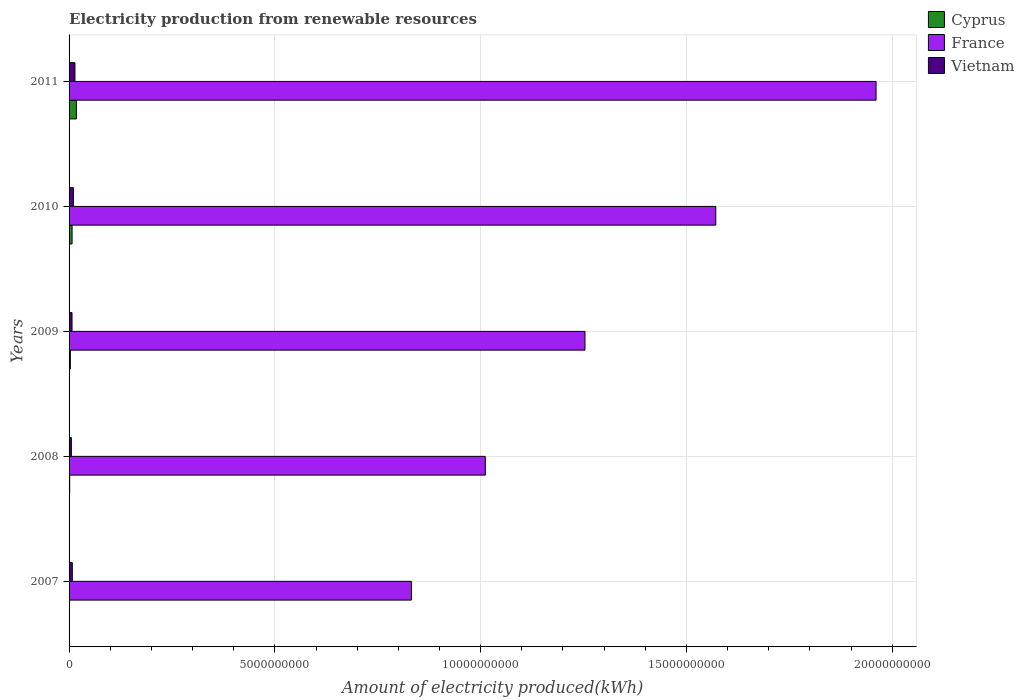How many different coloured bars are there?
Ensure brevity in your answer.  3. How many groups of bars are there?
Provide a succinct answer. 5. Are the number of bars per tick equal to the number of legend labels?
Your answer should be compact. Yes. Are the number of bars on each tick of the Y-axis equal?
Your answer should be very brief. Yes. How many bars are there on the 4th tick from the bottom?
Make the answer very short. 3. What is the label of the 5th group of bars from the top?
Give a very brief answer. 2007. What is the amount of electricity produced in Vietnam in 2010?
Your answer should be very brief. 1.05e+08. Across all years, what is the maximum amount of electricity produced in France?
Provide a short and direct response. 1.96e+1. Across all years, what is the minimum amount of electricity produced in Cyprus?
Give a very brief answer. 3.00e+06. What is the total amount of electricity produced in Vietnam in the graph?
Give a very brief answer. 4.55e+08. What is the difference between the amount of electricity produced in France in 2008 and that in 2010?
Provide a succinct answer. -5.60e+09. What is the difference between the amount of electricity produced in Vietnam in 2008 and the amount of electricity produced in Cyprus in 2007?
Your response must be concise. 5.30e+07. What is the average amount of electricity produced in France per year?
Provide a short and direct response. 1.33e+1. In the year 2007, what is the difference between the amount of electricity produced in Cyprus and amount of electricity produced in France?
Provide a short and direct response. -8.32e+09. In how many years, is the amount of electricity produced in Vietnam greater than 15000000000 kWh?
Provide a succinct answer. 0. What is the ratio of the amount of electricity produced in France in 2008 to that in 2010?
Make the answer very short. 0.64. Is the amount of electricity produced in Vietnam in 2008 less than that in 2011?
Your answer should be compact. Yes. Is the difference between the amount of electricity produced in Cyprus in 2007 and 2011 greater than the difference between the amount of electricity produced in France in 2007 and 2011?
Provide a short and direct response. Yes. What is the difference between the highest and the second highest amount of electricity produced in Cyprus?
Ensure brevity in your answer.  1.05e+08. What is the difference between the highest and the lowest amount of electricity produced in Vietnam?
Offer a terse response. 8.70e+07. In how many years, is the amount of electricity produced in France greater than the average amount of electricity produced in France taken over all years?
Your response must be concise. 2. What does the 3rd bar from the top in 2011 represents?
Your response must be concise. Cyprus. What does the 2nd bar from the bottom in 2007 represents?
Provide a short and direct response. France. Is it the case that in every year, the sum of the amount of electricity produced in France and amount of electricity produced in Cyprus is greater than the amount of electricity produced in Vietnam?
Provide a short and direct response. Yes. Are all the bars in the graph horizontal?
Provide a succinct answer. Yes. How many years are there in the graph?
Keep it short and to the point. 5. What is the difference between two consecutive major ticks on the X-axis?
Offer a terse response. 5.00e+09. Does the graph contain any zero values?
Your answer should be very brief. No. Does the graph contain grids?
Offer a terse response. Yes. Where does the legend appear in the graph?
Keep it short and to the point. Top right. What is the title of the graph?
Offer a terse response. Electricity production from renewable resources. What is the label or title of the X-axis?
Your answer should be compact. Amount of electricity produced(kWh). What is the label or title of the Y-axis?
Offer a terse response. Years. What is the Amount of electricity produced(kWh) in France in 2007?
Your answer should be compact. 8.32e+09. What is the Amount of electricity produced(kWh) in Vietnam in 2007?
Provide a short and direct response. 7.90e+07. What is the Amount of electricity produced(kWh) of Cyprus in 2008?
Make the answer very short. 1.50e+07. What is the Amount of electricity produced(kWh) of France in 2008?
Make the answer very short. 1.01e+1. What is the Amount of electricity produced(kWh) of Vietnam in 2008?
Provide a short and direct response. 5.60e+07. What is the Amount of electricity produced(kWh) in Cyprus in 2009?
Make the answer very short. 3.10e+07. What is the Amount of electricity produced(kWh) in France in 2009?
Provide a succinct answer. 1.25e+1. What is the Amount of electricity produced(kWh) in Vietnam in 2009?
Offer a very short reply. 7.20e+07. What is the Amount of electricity produced(kWh) in Cyprus in 2010?
Your response must be concise. 7.30e+07. What is the Amount of electricity produced(kWh) of France in 2010?
Keep it short and to the point. 1.57e+1. What is the Amount of electricity produced(kWh) in Vietnam in 2010?
Keep it short and to the point. 1.05e+08. What is the Amount of electricity produced(kWh) of Cyprus in 2011?
Offer a terse response. 1.78e+08. What is the Amount of electricity produced(kWh) of France in 2011?
Offer a terse response. 1.96e+1. What is the Amount of electricity produced(kWh) in Vietnam in 2011?
Provide a succinct answer. 1.43e+08. Across all years, what is the maximum Amount of electricity produced(kWh) of Cyprus?
Your answer should be compact. 1.78e+08. Across all years, what is the maximum Amount of electricity produced(kWh) of France?
Offer a very short reply. 1.96e+1. Across all years, what is the maximum Amount of electricity produced(kWh) of Vietnam?
Keep it short and to the point. 1.43e+08. Across all years, what is the minimum Amount of electricity produced(kWh) in France?
Offer a terse response. 8.32e+09. Across all years, what is the minimum Amount of electricity produced(kWh) in Vietnam?
Your answer should be very brief. 5.60e+07. What is the total Amount of electricity produced(kWh) in Cyprus in the graph?
Your answer should be very brief. 3.00e+08. What is the total Amount of electricity produced(kWh) of France in the graph?
Ensure brevity in your answer.  6.63e+1. What is the total Amount of electricity produced(kWh) of Vietnam in the graph?
Keep it short and to the point. 4.55e+08. What is the difference between the Amount of electricity produced(kWh) in Cyprus in 2007 and that in 2008?
Provide a short and direct response. -1.20e+07. What is the difference between the Amount of electricity produced(kWh) in France in 2007 and that in 2008?
Your response must be concise. -1.80e+09. What is the difference between the Amount of electricity produced(kWh) of Vietnam in 2007 and that in 2008?
Offer a terse response. 2.30e+07. What is the difference between the Amount of electricity produced(kWh) of Cyprus in 2007 and that in 2009?
Provide a short and direct response. -2.80e+07. What is the difference between the Amount of electricity produced(kWh) in France in 2007 and that in 2009?
Your response must be concise. -4.22e+09. What is the difference between the Amount of electricity produced(kWh) in Cyprus in 2007 and that in 2010?
Give a very brief answer. -7.00e+07. What is the difference between the Amount of electricity produced(kWh) of France in 2007 and that in 2010?
Offer a terse response. -7.40e+09. What is the difference between the Amount of electricity produced(kWh) of Vietnam in 2007 and that in 2010?
Ensure brevity in your answer.  -2.60e+07. What is the difference between the Amount of electricity produced(kWh) in Cyprus in 2007 and that in 2011?
Provide a succinct answer. -1.75e+08. What is the difference between the Amount of electricity produced(kWh) of France in 2007 and that in 2011?
Ensure brevity in your answer.  -1.13e+1. What is the difference between the Amount of electricity produced(kWh) of Vietnam in 2007 and that in 2011?
Make the answer very short. -6.40e+07. What is the difference between the Amount of electricity produced(kWh) of Cyprus in 2008 and that in 2009?
Keep it short and to the point. -1.60e+07. What is the difference between the Amount of electricity produced(kWh) in France in 2008 and that in 2009?
Give a very brief answer. -2.42e+09. What is the difference between the Amount of electricity produced(kWh) of Vietnam in 2008 and that in 2009?
Give a very brief answer. -1.60e+07. What is the difference between the Amount of electricity produced(kWh) of Cyprus in 2008 and that in 2010?
Make the answer very short. -5.80e+07. What is the difference between the Amount of electricity produced(kWh) of France in 2008 and that in 2010?
Provide a succinct answer. -5.60e+09. What is the difference between the Amount of electricity produced(kWh) in Vietnam in 2008 and that in 2010?
Provide a succinct answer. -4.90e+07. What is the difference between the Amount of electricity produced(kWh) of Cyprus in 2008 and that in 2011?
Offer a terse response. -1.63e+08. What is the difference between the Amount of electricity produced(kWh) in France in 2008 and that in 2011?
Ensure brevity in your answer.  -9.49e+09. What is the difference between the Amount of electricity produced(kWh) of Vietnam in 2008 and that in 2011?
Offer a terse response. -8.70e+07. What is the difference between the Amount of electricity produced(kWh) of Cyprus in 2009 and that in 2010?
Provide a succinct answer. -4.20e+07. What is the difference between the Amount of electricity produced(kWh) in France in 2009 and that in 2010?
Your answer should be very brief. -3.18e+09. What is the difference between the Amount of electricity produced(kWh) in Vietnam in 2009 and that in 2010?
Your response must be concise. -3.30e+07. What is the difference between the Amount of electricity produced(kWh) of Cyprus in 2009 and that in 2011?
Provide a short and direct response. -1.47e+08. What is the difference between the Amount of electricity produced(kWh) of France in 2009 and that in 2011?
Ensure brevity in your answer.  -7.07e+09. What is the difference between the Amount of electricity produced(kWh) of Vietnam in 2009 and that in 2011?
Your answer should be compact. -7.10e+07. What is the difference between the Amount of electricity produced(kWh) in Cyprus in 2010 and that in 2011?
Offer a very short reply. -1.05e+08. What is the difference between the Amount of electricity produced(kWh) in France in 2010 and that in 2011?
Give a very brief answer. -3.89e+09. What is the difference between the Amount of electricity produced(kWh) in Vietnam in 2010 and that in 2011?
Your answer should be very brief. -3.80e+07. What is the difference between the Amount of electricity produced(kWh) in Cyprus in 2007 and the Amount of electricity produced(kWh) in France in 2008?
Give a very brief answer. -1.01e+1. What is the difference between the Amount of electricity produced(kWh) of Cyprus in 2007 and the Amount of electricity produced(kWh) of Vietnam in 2008?
Your response must be concise. -5.30e+07. What is the difference between the Amount of electricity produced(kWh) in France in 2007 and the Amount of electricity produced(kWh) in Vietnam in 2008?
Offer a terse response. 8.26e+09. What is the difference between the Amount of electricity produced(kWh) of Cyprus in 2007 and the Amount of electricity produced(kWh) of France in 2009?
Offer a very short reply. -1.25e+1. What is the difference between the Amount of electricity produced(kWh) in Cyprus in 2007 and the Amount of electricity produced(kWh) in Vietnam in 2009?
Offer a terse response. -6.90e+07. What is the difference between the Amount of electricity produced(kWh) of France in 2007 and the Amount of electricity produced(kWh) of Vietnam in 2009?
Give a very brief answer. 8.25e+09. What is the difference between the Amount of electricity produced(kWh) of Cyprus in 2007 and the Amount of electricity produced(kWh) of France in 2010?
Make the answer very short. -1.57e+1. What is the difference between the Amount of electricity produced(kWh) of Cyprus in 2007 and the Amount of electricity produced(kWh) of Vietnam in 2010?
Provide a short and direct response. -1.02e+08. What is the difference between the Amount of electricity produced(kWh) of France in 2007 and the Amount of electricity produced(kWh) of Vietnam in 2010?
Provide a short and direct response. 8.21e+09. What is the difference between the Amount of electricity produced(kWh) of Cyprus in 2007 and the Amount of electricity produced(kWh) of France in 2011?
Ensure brevity in your answer.  -1.96e+1. What is the difference between the Amount of electricity produced(kWh) in Cyprus in 2007 and the Amount of electricity produced(kWh) in Vietnam in 2011?
Make the answer very short. -1.40e+08. What is the difference between the Amount of electricity produced(kWh) of France in 2007 and the Amount of electricity produced(kWh) of Vietnam in 2011?
Your response must be concise. 8.18e+09. What is the difference between the Amount of electricity produced(kWh) of Cyprus in 2008 and the Amount of electricity produced(kWh) of France in 2009?
Ensure brevity in your answer.  -1.25e+1. What is the difference between the Amount of electricity produced(kWh) in Cyprus in 2008 and the Amount of electricity produced(kWh) in Vietnam in 2009?
Provide a short and direct response. -5.70e+07. What is the difference between the Amount of electricity produced(kWh) in France in 2008 and the Amount of electricity produced(kWh) in Vietnam in 2009?
Ensure brevity in your answer.  1.00e+1. What is the difference between the Amount of electricity produced(kWh) in Cyprus in 2008 and the Amount of electricity produced(kWh) in France in 2010?
Offer a very short reply. -1.57e+1. What is the difference between the Amount of electricity produced(kWh) of Cyprus in 2008 and the Amount of electricity produced(kWh) of Vietnam in 2010?
Keep it short and to the point. -9.00e+07. What is the difference between the Amount of electricity produced(kWh) of France in 2008 and the Amount of electricity produced(kWh) of Vietnam in 2010?
Your answer should be very brief. 1.00e+1. What is the difference between the Amount of electricity produced(kWh) in Cyprus in 2008 and the Amount of electricity produced(kWh) in France in 2011?
Offer a very short reply. -1.96e+1. What is the difference between the Amount of electricity produced(kWh) of Cyprus in 2008 and the Amount of electricity produced(kWh) of Vietnam in 2011?
Provide a short and direct response. -1.28e+08. What is the difference between the Amount of electricity produced(kWh) in France in 2008 and the Amount of electricity produced(kWh) in Vietnam in 2011?
Provide a short and direct response. 9.97e+09. What is the difference between the Amount of electricity produced(kWh) of Cyprus in 2009 and the Amount of electricity produced(kWh) of France in 2010?
Give a very brief answer. -1.57e+1. What is the difference between the Amount of electricity produced(kWh) in Cyprus in 2009 and the Amount of electricity produced(kWh) in Vietnam in 2010?
Your answer should be compact. -7.40e+07. What is the difference between the Amount of electricity produced(kWh) in France in 2009 and the Amount of electricity produced(kWh) in Vietnam in 2010?
Ensure brevity in your answer.  1.24e+1. What is the difference between the Amount of electricity produced(kWh) of Cyprus in 2009 and the Amount of electricity produced(kWh) of France in 2011?
Offer a very short reply. -1.96e+1. What is the difference between the Amount of electricity produced(kWh) of Cyprus in 2009 and the Amount of electricity produced(kWh) of Vietnam in 2011?
Offer a very short reply. -1.12e+08. What is the difference between the Amount of electricity produced(kWh) of France in 2009 and the Amount of electricity produced(kWh) of Vietnam in 2011?
Your response must be concise. 1.24e+1. What is the difference between the Amount of electricity produced(kWh) in Cyprus in 2010 and the Amount of electricity produced(kWh) in France in 2011?
Make the answer very short. -1.95e+1. What is the difference between the Amount of electricity produced(kWh) of Cyprus in 2010 and the Amount of electricity produced(kWh) of Vietnam in 2011?
Your answer should be compact. -7.00e+07. What is the difference between the Amount of electricity produced(kWh) of France in 2010 and the Amount of electricity produced(kWh) of Vietnam in 2011?
Make the answer very short. 1.56e+1. What is the average Amount of electricity produced(kWh) of Cyprus per year?
Your answer should be compact. 6.00e+07. What is the average Amount of electricity produced(kWh) of France per year?
Your response must be concise. 1.33e+1. What is the average Amount of electricity produced(kWh) in Vietnam per year?
Your answer should be compact. 9.10e+07. In the year 2007, what is the difference between the Amount of electricity produced(kWh) of Cyprus and Amount of electricity produced(kWh) of France?
Make the answer very short. -8.32e+09. In the year 2007, what is the difference between the Amount of electricity produced(kWh) in Cyprus and Amount of electricity produced(kWh) in Vietnam?
Make the answer very short. -7.60e+07. In the year 2007, what is the difference between the Amount of electricity produced(kWh) in France and Amount of electricity produced(kWh) in Vietnam?
Give a very brief answer. 8.24e+09. In the year 2008, what is the difference between the Amount of electricity produced(kWh) of Cyprus and Amount of electricity produced(kWh) of France?
Provide a short and direct response. -1.01e+1. In the year 2008, what is the difference between the Amount of electricity produced(kWh) of Cyprus and Amount of electricity produced(kWh) of Vietnam?
Keep it short and to the point. -4.10e+07. In the year 2008, what is the difference between the Amount of electricity produced(kWh) in France and Amount of electricity produced(kWh) in Vietnam?
Give a very brief answer. 1.01e+1. In the year 2009, what is the difference between the Amount of electricity produced(kWh) of Cyprus and Amount of electricity produced(kWh) of France?
Offer a terse response. -1.25e+1. In the year 2009, what is the difference between the Amount of electricity produced(kWh) in Cyprus and Amount of electricity produced(kWh) in Vietnam?
Keep it short and to the point. -4.10e+07. In the year 2009, what is the difference between the Amount of electricity produced(kWh) in France and Amount of electricity produced(kWh) in Vietnam?
Provide a short and direct response. 1.25e+1. In the year 2010, what is the difference between the Amount of electricity produced(kWh) of Cyprus and Amount of electricity produced(kWh) of France?
Provide a succinct answer. -1.56e+1. In the year 2010, what is the difference between the Amount of electricity produced(kWh) in Cyprus and Amount of electricity produced(kWh) in Vietnam?
Provide a short and direct response. -3.20e+07. In the year 2010, what is the difference between the Amount of electricity produced(kWh) of France and Amount of electricity produced(kWh) of Vietnam?
Offer a very short reply. 1.56e+1. In the year 2011, what is the difference between the Amount of electricity produced(kWh) of Cyprus and Amount of electricity produced(kWh) of France?
Make the answer very short. -1.94e+1. In the year 2011, what is the difference between the Amount of electricity produced(kWh) of Cyprus and Amount of electricity produced(kWh) of Vietnam?
Your response must be concise. 3.50e+07. In the year 2011, what is the difference between the Amount of electricity produced(kWh) in France and Amount of electricity produced(kWh) in Vietnam?
Offer a very short reply. 1.95e+1. What is the ratio of the Amount of electricity produced(kWh) in France in 2007 to that in 2008?
Give a very brief answer. 0.82. What is the ratio of the Amount of electricity produced(kWh) of Vietnam in 2007 to that in 2008?
Your answer should be compact. 1.41. What is the ratio of the Amount of electricity produced(kWh) in Cyprus in 2007 to that in 2009?
Provide a short and direct response. 0.1. What is the ratio of the Amount of electricity produced(kWh) in France in 2007 to that in 2009?
Provide a succinct answer. 0.66. What is the ratio of the Amount of electricity produced(kWh) in Vietnam in 2007 to that in 2009?
Provide a short and direct response. 1.1. What is the ratio of the Amount of electricity produced(kWh) of Cyprus in 2007 to that in 2010?
Offer a very short reply. 0.04. What is the ratio of the Amount of electricity produced(kWh) of France in 2007 to that in 2010?
Give a very brief answer. 0.53. What is the ratio of the Amount of electricity produced(kWh) of Vietnam in 2007 to that in 2010?
Offer a very short reply. 0.75. What is the ratio of the Amount of electricity produced(kWh) in Cyprus in 2007 to that in 2011?
Your answer should be very brief. 0.02. What is the ratio of the Amount of electricity produced(kWh) in France in 2007 to that in 2011?
Provide a short and direct response. 0.42. What is the ratio of the Amount of electricity produced(kWh) in Vietnam in 2007 to that in 2011?
Offer a very short reply. 0.55. What is the ratio of the Amount of electricity produced(kWh) in Cyprus in 2008 to that in 2009?
Make the answer very short. 0.48. What is the ratio of the Amount of electricity produced(kWh) in France in 2008 to that in 2009?
Ensure brevity in your answer.  0.81. What is the ratio of the Amount of electricity produced(kWh) of Cyprus in 2008 to that in 2010?
Ensure brevity in your answer.  0.21. What is the ratio of the Amount of electricity produced(kWh) of France in 2008 to that in 2010?
Offer a very short reply. 0.64. What is the ratio of the Amount of electricity produced(kWh) of Vietnam in 2008 to that in 2010?
Your response must be concise. 0.53. What is the ratio of the Amount of electricity produced(kWh) in Cyprus in 2008 to that in 2011?
Provide a succinct answer. 0.08. What is the ratio of the Amount of electricity produced(kWh) of France in 2008 to that in 2011?
Offer a very short reply. 0.52. What is the ratio of the Amount of electricity produced(kWh) in Vietnam in 2008 to that in 2011?
Offer a terse response. 0.39. What is the ratio of the Amount of electricity produced(kWh) of Cyprus in 2009 to that in 2010?
Keep it short and to the point. 0.42. What is the ratio of the Amount of electricity produced(kWh) in France in 2009 to that in 2010?
Keep it short and to the point. 0.8. What is the ratio of the Amount of electricity produced(kWh) in Vietnam in 2009 to that in 2010?
Keep it short and to the point. 0.69. What is the ratio of the Amount of electricity produced(kWh) of Cyprus in 2009 to that in 2011?
Give a very brief answer. 0.17. What is the ratio of the Amount of electricity produced(kWh) in France in 2009 to that in 2011?
Provide a succinct answer. 0.64. What is the ratio of the Amount of electricity produced(kWh) of Vietnam in 2009 to that in 2011?
Provide a succinct answer. 0.5. What is the ratio of the Amount of electricity produced(kWh) in Cyprus in 2010 to that in 2011?
Provide a succinct answer. 0.41. What is the ratio of the Amount of electricity produced(kWh) of France in 2010 to that in 2011?
Offer a very short reply. 0.8. What is the ratio of the Amount of electricity produced(kWh) in Vietnam in 2010 to that in 2011?
Your answer should be very brief. 0.73. What is the difference between the highest and the second highest Amount of electricity produced(kWh) of Cyprus?
Your response must be concise. 1.05e+08. What is the difference between the highest and the second highest Amount of electricity produced(kWh) of France?
Make the answer very short. 3.89e+09. What is the difference between the highest and the second highest Amount of electricity produced(kWh) of Vietnam?
Give a very brief answer. 3.80e+07. What is the difference between the highest and the lowest Amount of electricity produced(kWh) in Cyprus?
Offer a terse response. 1.75e+08. What is the difference between the highest and the lowest Amount of electricity produced(kWh) of France?
Ensure brevity in your answer.  1.13e+1. What is the difference between the highest and the lowest Amount of electricity produced(kWh) of Vietnam?
Keep it short and to the point. 8.70e+07. 